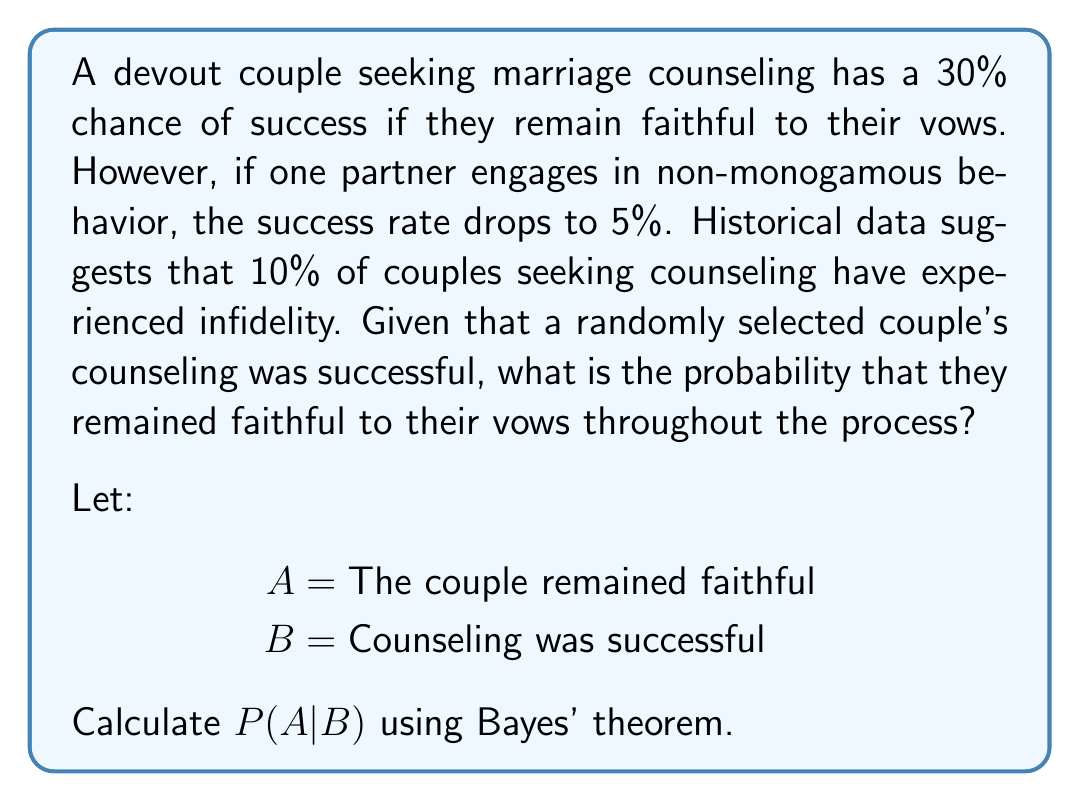Show me your answer to this math problem. To solve this problem, we'll use Bayes' theorem:

$$P(A|B) = \frac{P(B|A) \cdot P(A)}{P(B)}$$

Given:
- $P(B|A) = 0.30$ (30% success rate if faithful)
- $P(B|\text{not }A) = 0.05$ (5% success rate if unfaithful)
- $P(A) = 0.90$ (90% of couples remain faithful)
- $P(\text{not }A) = 0.10$ (10% of couples experience infidelity)

Step 1: Calculate $P(B)$ using the law of total probability:
$$P(B) = P(B|A) \cdot P(A) + P(B|\text{not }A) \cdot P(\text{not }A)$$
$$P(B) = 0.30 \cdot 0.90 + 0.05 \cdot 0.10 = 0.275$$

Step 2: Apply Bayes' theorem:
$$P(A|B) = \frac{P(B|A) \cdot P(A)}{P(B)}$$
$$P(A|B) = \frac{0.30 \cdot 0.90}{0.275}$$
$$P(A|B) = \frac{0.27}{0.275} \approx 0.9818$$

Therefore, the probability that the couple remained faithful given that their counseling was successful is approximately 0.9818 or 98.18%.
Answer: $P(A|B) \approx 0.9818$ or 98.18% 